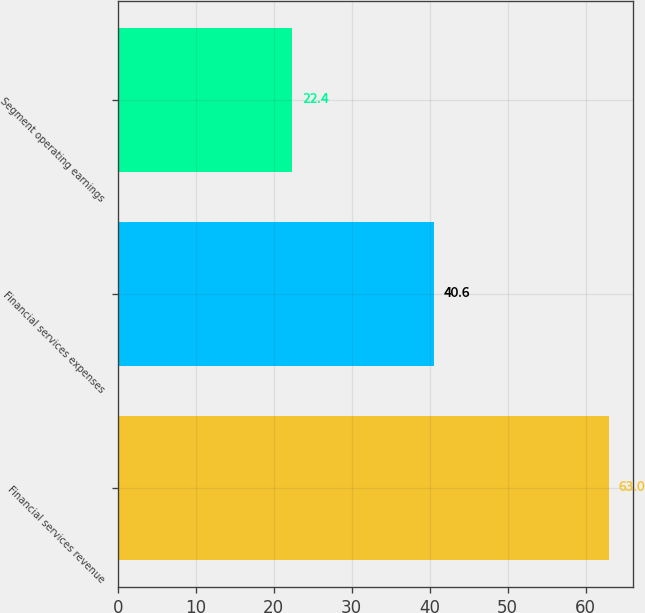Convert chart to OTSL. <chart><loc_0><loc_0><loc_500><loc_500><bar_chart><fcel>Financial services revenue<fcel>Financial services expenses<fcel>Segment operating earnings<nl><fcel>63<fcel>40.6<fcel>22.4<nl></chart> 